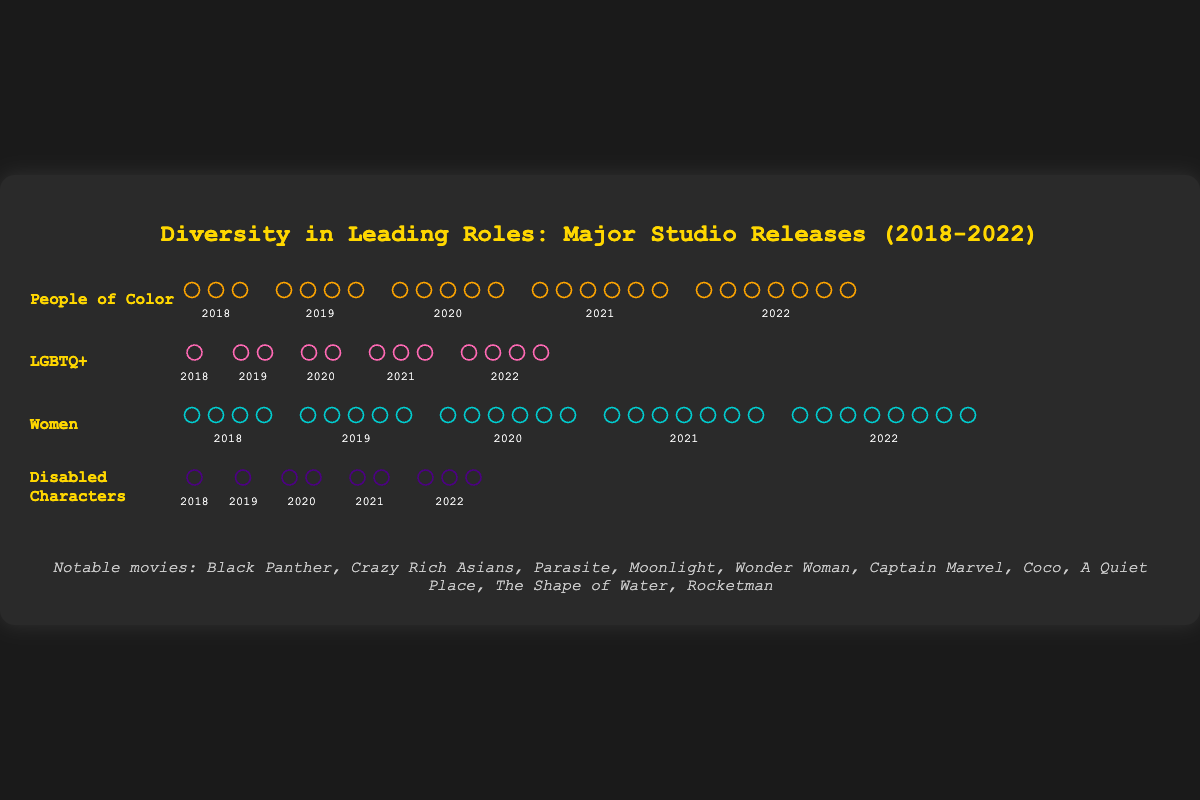What is the title of the figure? The title of the figure is displayed at the top of the chart in a large, colorful font. It is meant to give an overview of what the data represents.
Answer: Diversity in Leading Roles: Major Studio Releases (2018-2022) How many leading roles were represented by People of Color in 2021? The row labeled "People of Color" shows icons that correspond to each year. Count the number of icons in the "2021" column.
Answer: 6 Which category saw an increase in representation every year? Look for the category that has an increasing number of icons each year without any decrease.
Answer: People of Color How many total leading roles were represented by LGBTQ+ characters over the five years? Count the total number of LGBTQ+ icons across all the years and sum them.
Answer: 1 + 2 + 2 + 3 + 4 = 12 Which year had the highest number of leading roles represented by women? Check the row labeled "Women" and identify the year with the most icons.
Answer: 2022 Which category had the least representation in 2018? Compare the number of icons for all categories in the year 2018 to find the smallest number.
Answer: Disabled Characters What is the increase in the number of leading roles for People of Color from 2018 to 2022? Subtract the number of icons in 2018 from the number of icons in 2022 in the "People of Color" category.
Answer: 7 - 3 = 4 What is the difference in the representation of LGBTQ+ characters between 2020 and 2021? Subtract the number of icons in 2020 from the number of icons in 2021 in the "LGBTQ+" category.
Answer: 3 - 2 = 1 How many more women leading roles were there in 2022 compared to 2018? Subtract the number of "Women" icons in 2018 from those in 2022 to get the difference.
Answer: 8 - 4 = 4 